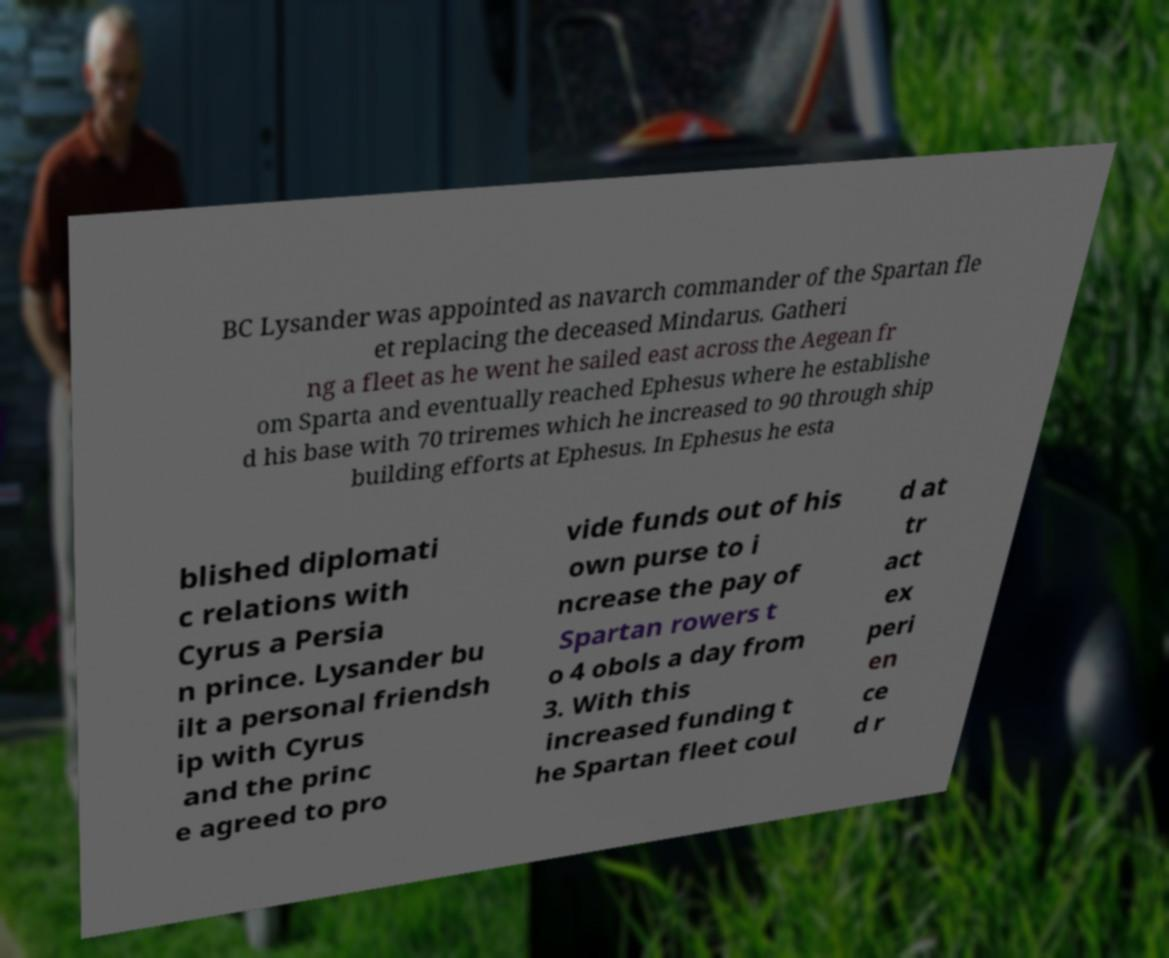Can you read and provide the text displayed in the image?This photo seems to have some interesting text. Can you extract and type it out for me? BC Lysander was appointed as navarch commander of the Spartan fle et replacing the deceased Mindarus. Gatheri ng a fleet as he went he sailed east across the Aegean fr om Sparta and eventually reached Ephesus where he establishe d his base with 70 triremes which he increased to 90 through ship building efforts at Ephesus. In Ephesus he esta blished diplomati c relations with Cyrus a Persia n prince. Lysander bu ilt a personal friendsh ip with Cyrus and the princ e agreed to pro vide funds out of his own purse to i ncrease the pay of Spartan rowers t o 4 obols a day from 3. With this increased funding t he Spartan fleet coul d at tr act ex peri en ce d r 